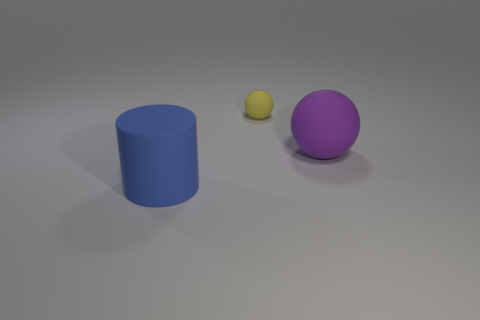Can you describe the lighting and shadows in the image? The lighting in the image comes from the top-left direction, as the shadows cast by the objects stretch towards the bottom-right. This illumination creates a soft shadow for each object, indicating a general diffused light source. 